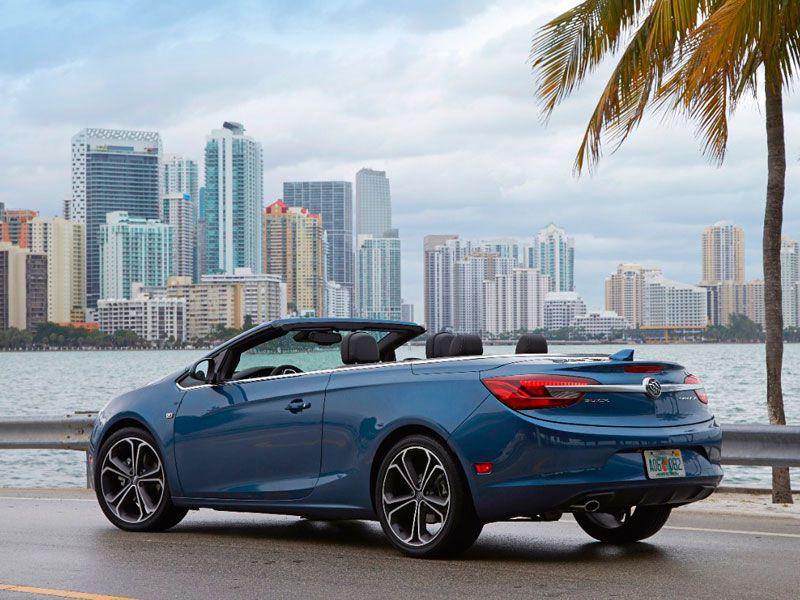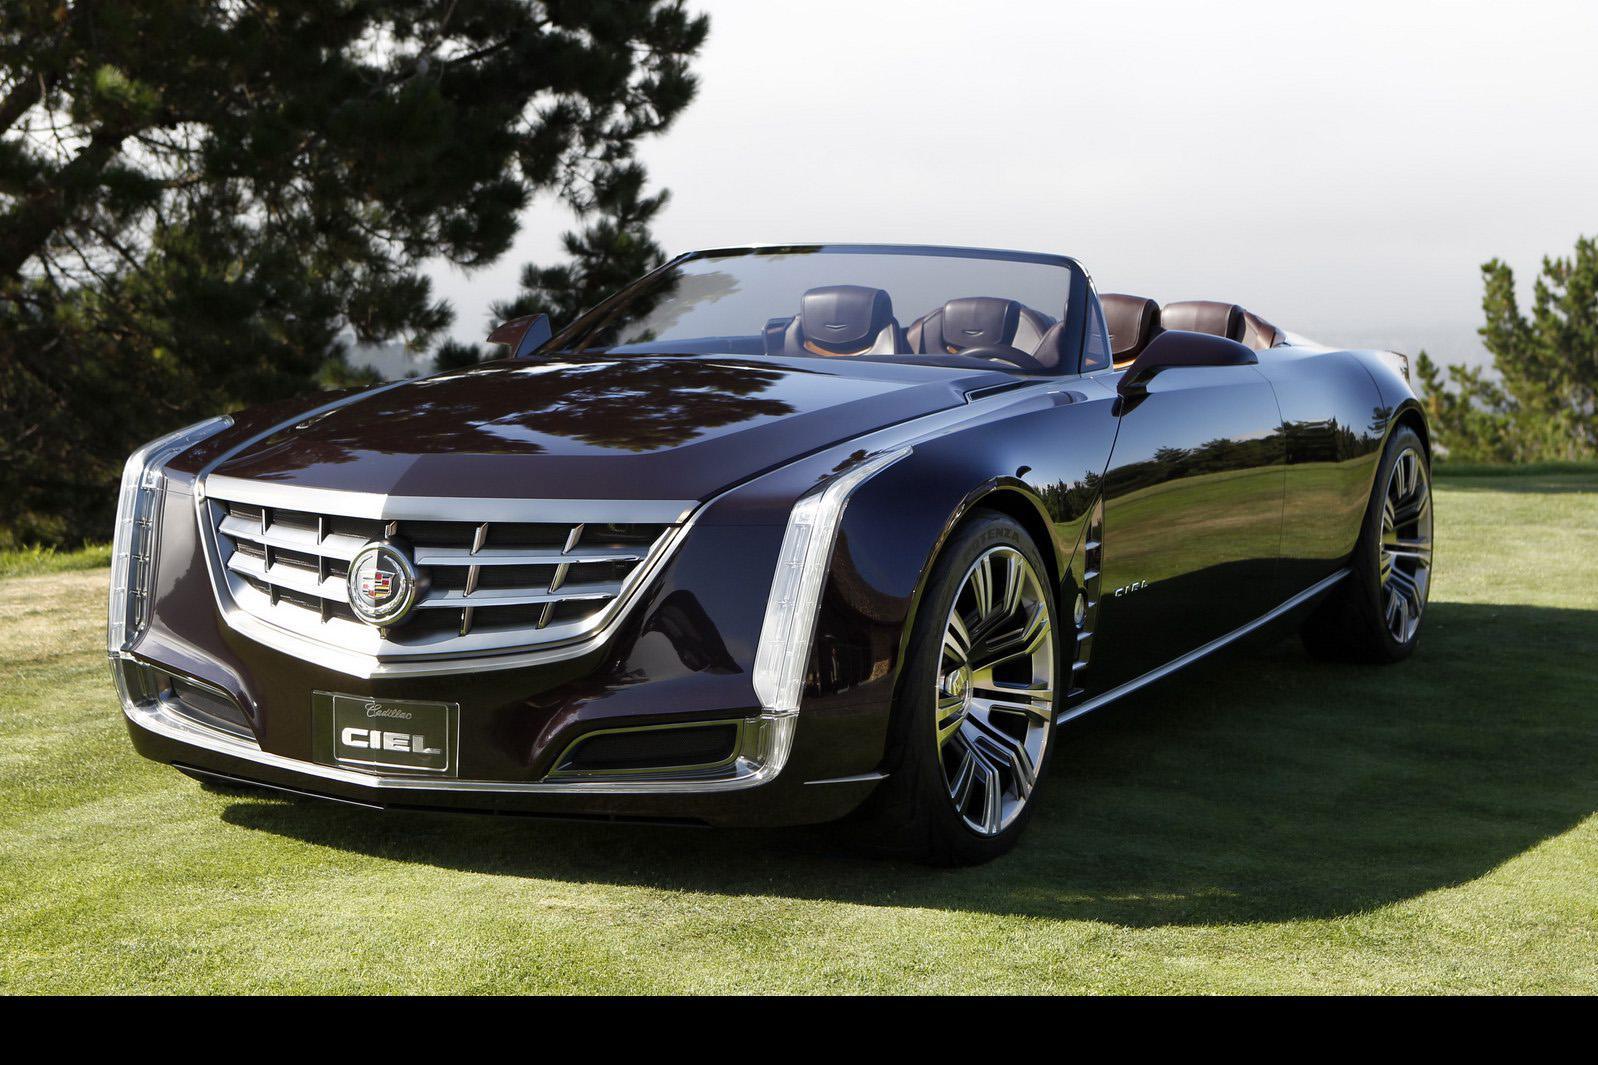The first image is the image on the left, the second image is the image on the right. Examine the images to the left and right. Is the description "One of the convertibles is red." accurate? Answer yes or no. No. The first image is the image on the left, the second image is the image on the right. Evaluate the accuracy of this statement regarding the images: "a convertible is parked on a sandy lot with grass in the background". Is it true? Answer yes or no. No. 